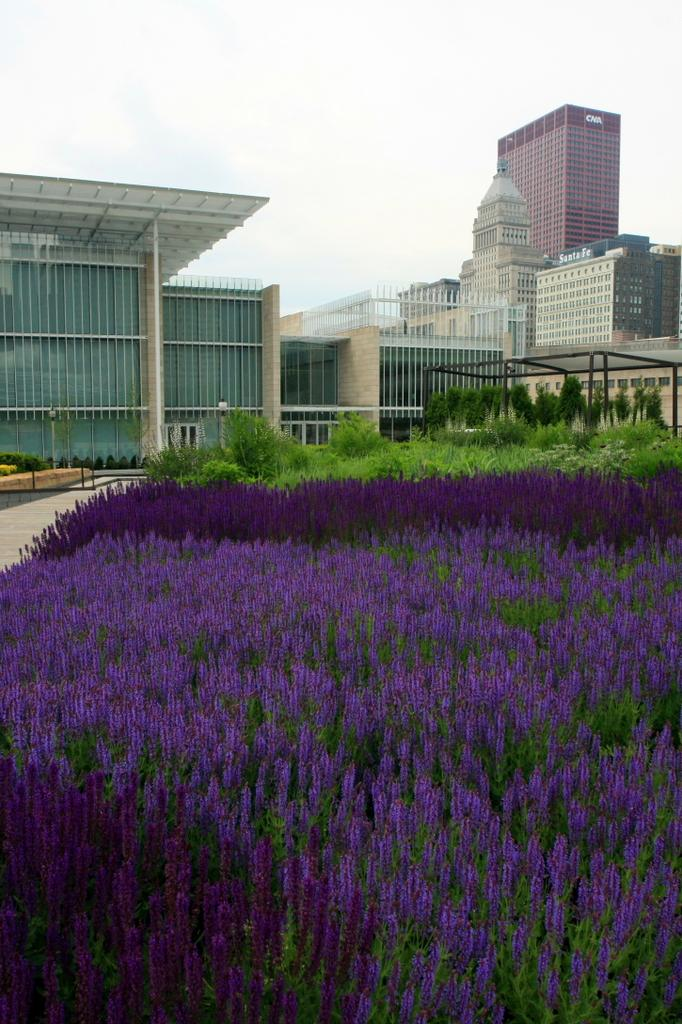What types of vegetation are at the bottom of the image? There are plants and flowers at the bottom of the image. What structures can be seen in the center of the image? There are buildings in the center of the image. What is visible at the top of the image? The sky is visible at the top of the image. What pathway is located on the left side of the image? There is a walkway on the left side of the image. How much sugar is present in the image? There is no sugar present in the image. What type of fan can be seen in the image? There is no fan present in the image. 